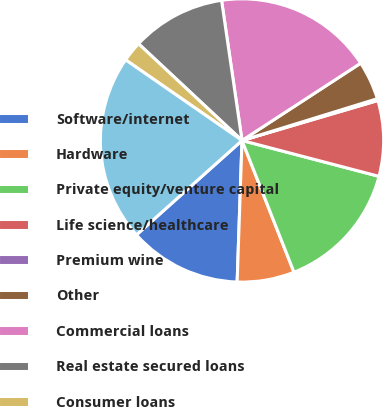Convert chart. <chart><loc_0><loc_0><loc_500><loc_500><pie_chart><fcel>Software/internet<fcel>Hardware<fcel>Private equity/venture capital<fcel>Life science/healthcare<fcel>Premium wine<fcel>Other<fcel>Commercial loans<fcel>Real estate secured loans<fcel>Consumer loans<fcel>Total gross loans<nl><fcel>12.84%<fcel>6.53%<fcel>14.94%<fcel>8.63%<fcel>0.21%<fcel>4.42%<fcel>18.12%<fcel>10.73%<fcel>2.32%<fcel>21.25%<nl></chart> 